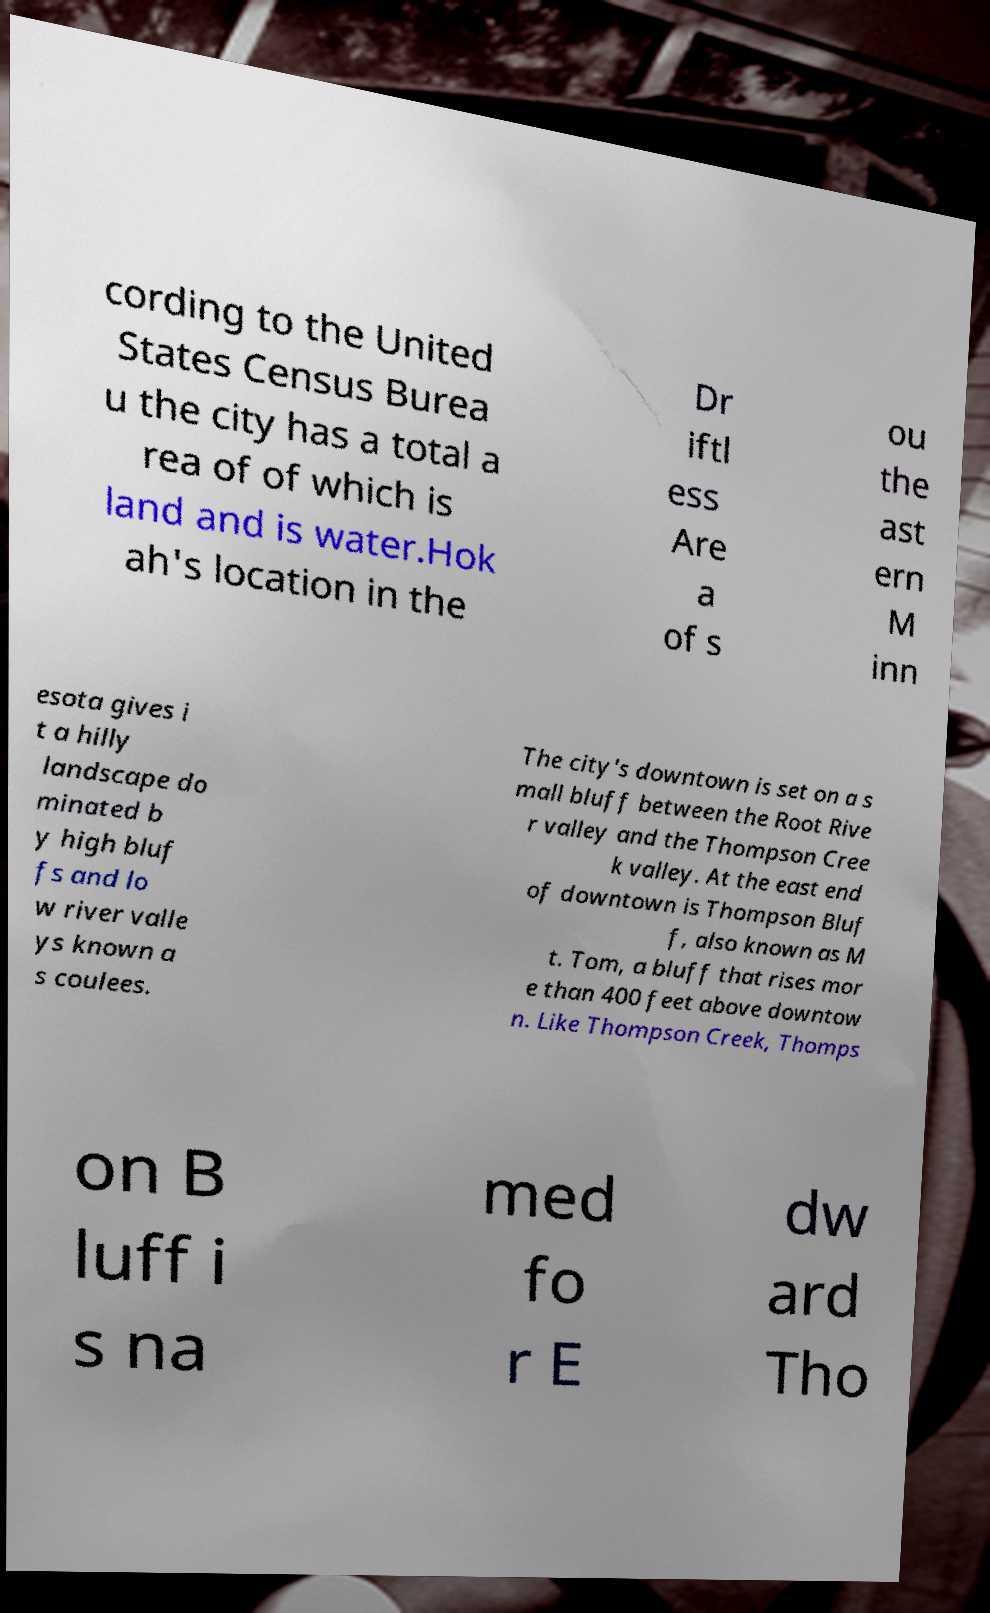For documentation purposes, I need the text within this image transcribed. Could you provide that? cording to the United States Census Burea u the city has a total a rea of of which is land and is water.Hok ah's location in the Dr iftl ess Are a of s ou the ast ern M inn esota gives i t a hilly landscape do minated b y high bluf fs and lo w river valle ys known a s coulees. The city's downtown is set on a s mall bluff between the Root Rive r valley and the Thompson Cree k valley. At the east end of downtown is Thompson Bluf f, also known as M t. Tom, a bluff that rises mor e than 400 feet above downtow n. Like Thompson Creek, Thomps on B luff i s na med fo r E dw ard Tho 